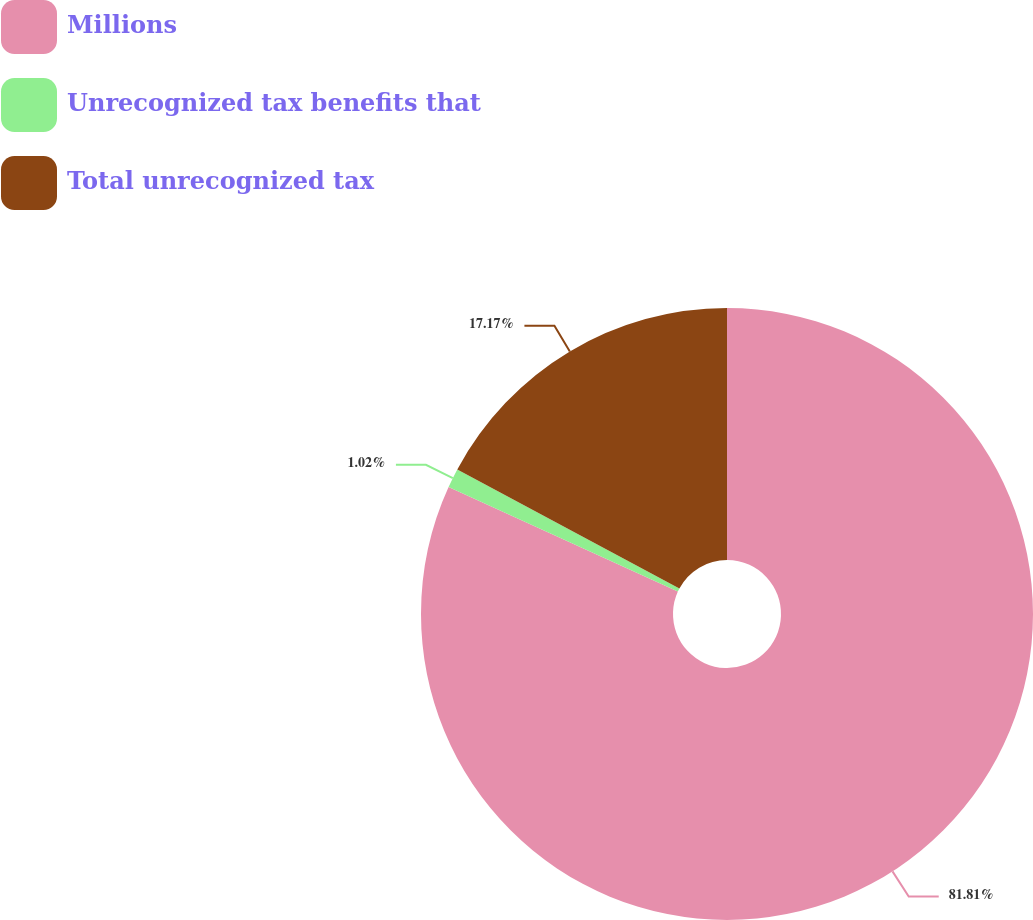Convert chart to OTSL. <chart><loc_0><loc_0><loc_500><loc_500><pie_chart><fcel>Millions<fcel>Unrecognized tax benefits that<fcel>Total unrecognized tax<nl><fcel>81.81%<fcel>1.02%<fcel>17.17%<nl></chart> 